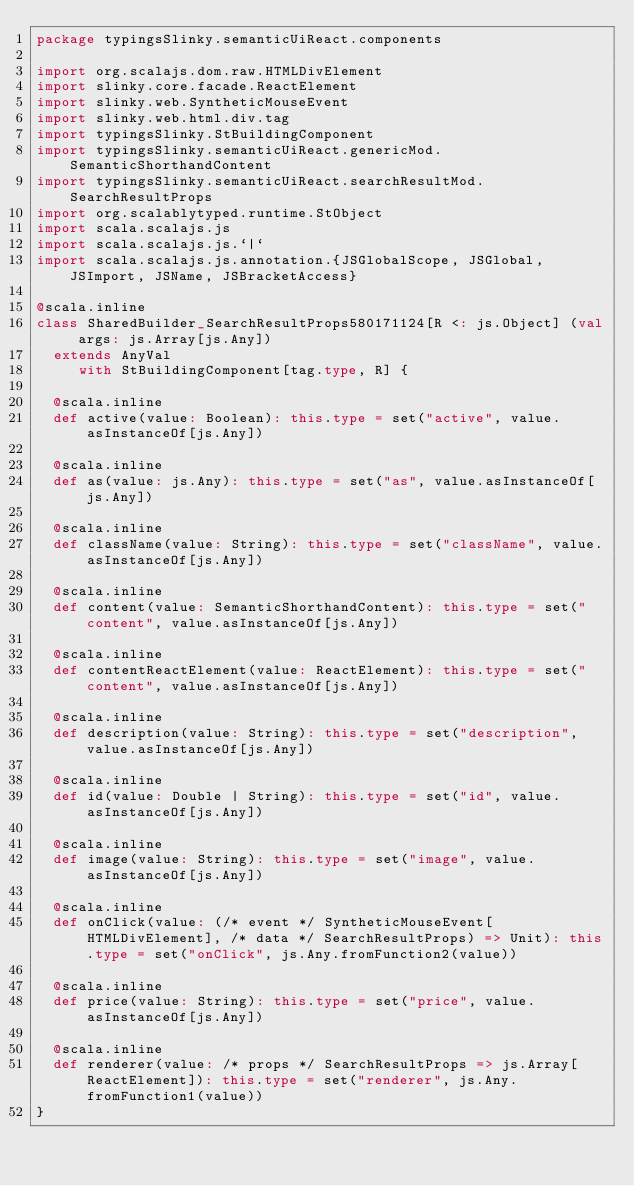Convert code to text. <code><loc_0><loc_0><loc_500><loc_500><_Scala_>package typingsSlinky.semanticUiReact.components

import org.scalajs.dom.raw.HTMLDivElement
import slinky.core.facade.ReactElement
import slinky.web.SyntheticMouseEvent
import slinky.web.html.div.tag
import typingsSlinky.StBuildingComponent
import typingsSlinky.semanticUiReact.genericMod.SemanticShorthandContent
import typingsSlinky.semanticUiReact.searchResultMod.SearchResultProps
import org.scalablytyped.runtime.StObject
import scala.scalajs.js
import scala.scalajs.js.`|`
import scala.scalajs.js.annotation.{JSGlobalScope, JSGlobal, JSImport, JSName, JSBracketAccess}

@scala.inline
class SharedBuilder_SearchResultProps580171124[R <: js.Object] (val args: js.Array[js.Any])
  extends AnyVal
     with StBuildingComponent[tag.type, R] {
  
  @scala.inline
  def active(value: Boolean): this.type = set("active", value.asInstanceOf[js.Any])
  
  @scala.inline
  def as(value: js.Any): this.type = set("as", value.asInstanceOf[js.Any])
  
  @scala.inline
  def className(value: String): this.type = set("className", value.asInstanceOf[js.Any])
  
  @scala.inline
  def content(value: SemanticShorthandContent): this.type = set("content", value.asInstanceOf[js.Any])
  
  @scala.inline
  def contentReactElement(value: ReactElement): this.type = set("content", value.asInstanceOf[js.Any])
  
  @scala.inline
  def description(value: String): this.type = set("description", value.asInstanceOf[js.Any])
  
  @scala.inline
  def id(value: Double | String): this.type = set("id", value.asInstanceOf[js.Any])
  
  @scala.inline
  def image(value: String): this.type = set("image", value.asInstanceOf[js.Any])
  
  @scala.inline
  def onClick(value: (/* event */ SyntheticMouseEvent[HTMLDivElement], /* data */ SearchResultProps) => Unit): this.type = set("onClick", js.Any.fromFunction2(value))
  
  @scala.inline
  def price(value: String): this.type = set("price", value.asInstanceOf[js.Any])
  
  @scala.inline
  def renderer(value: /* props */ SearchResultProps => js.Array[ReactElement]): this.type = set("renderer", js.Any.fromFunction1(value))
}
</code> 